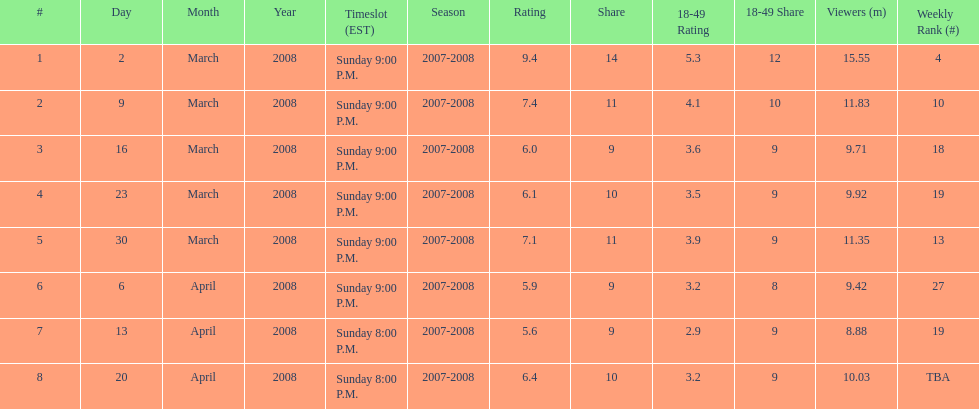Did the season finish at an earlier or later timeslot? Earlier. 